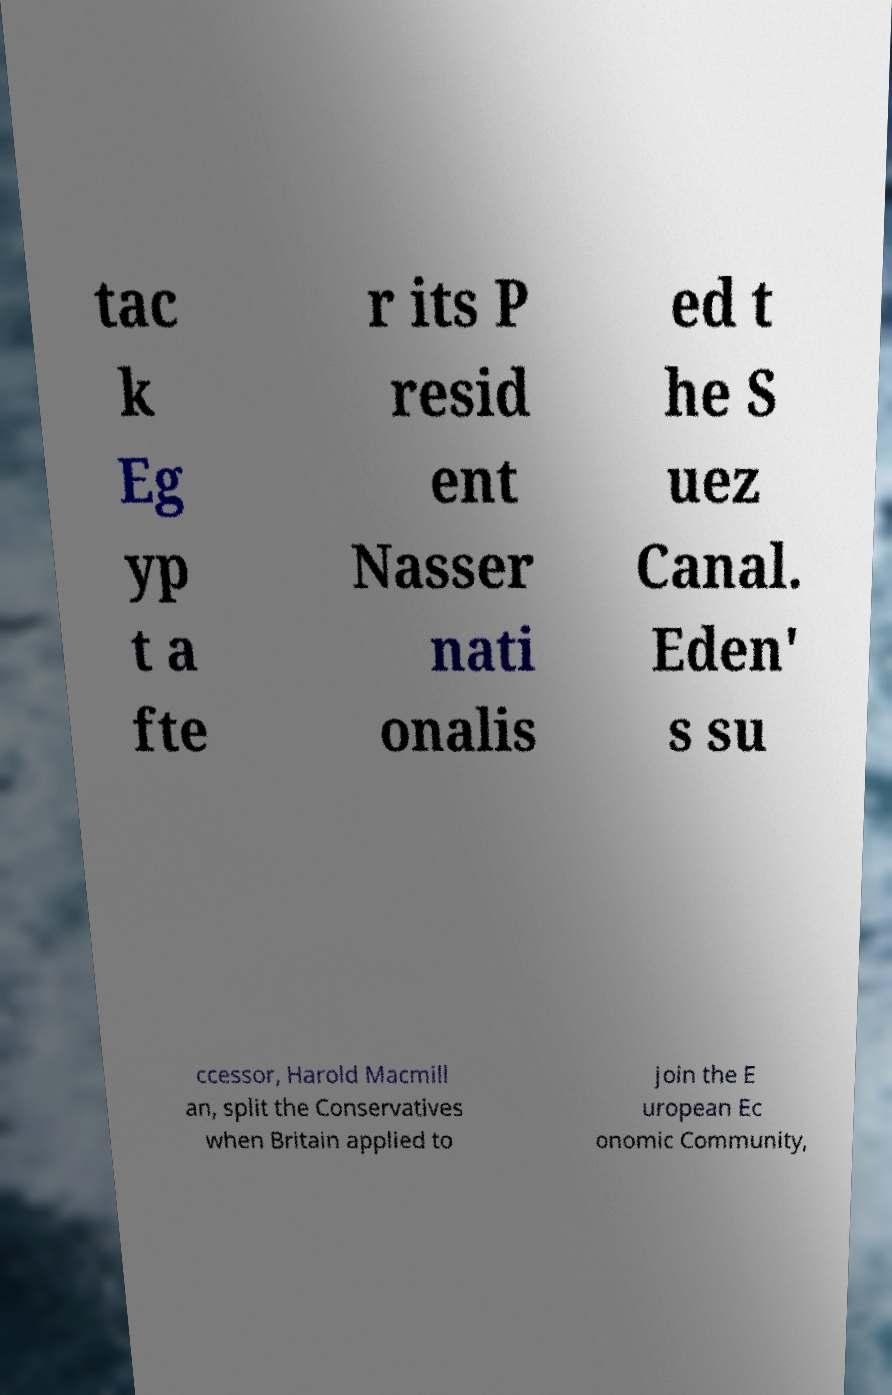For documentation purposes, I need the text within this image transcribed. Could you provide that? tac k Eg yp t a fte r its P resid ent Nasser nati onalis ed t he S uez Canal. Eden' s su ccessor, Harold Macmill an, split the Conservatives when Britain applied to join the E uropean Ec onomic Community, 